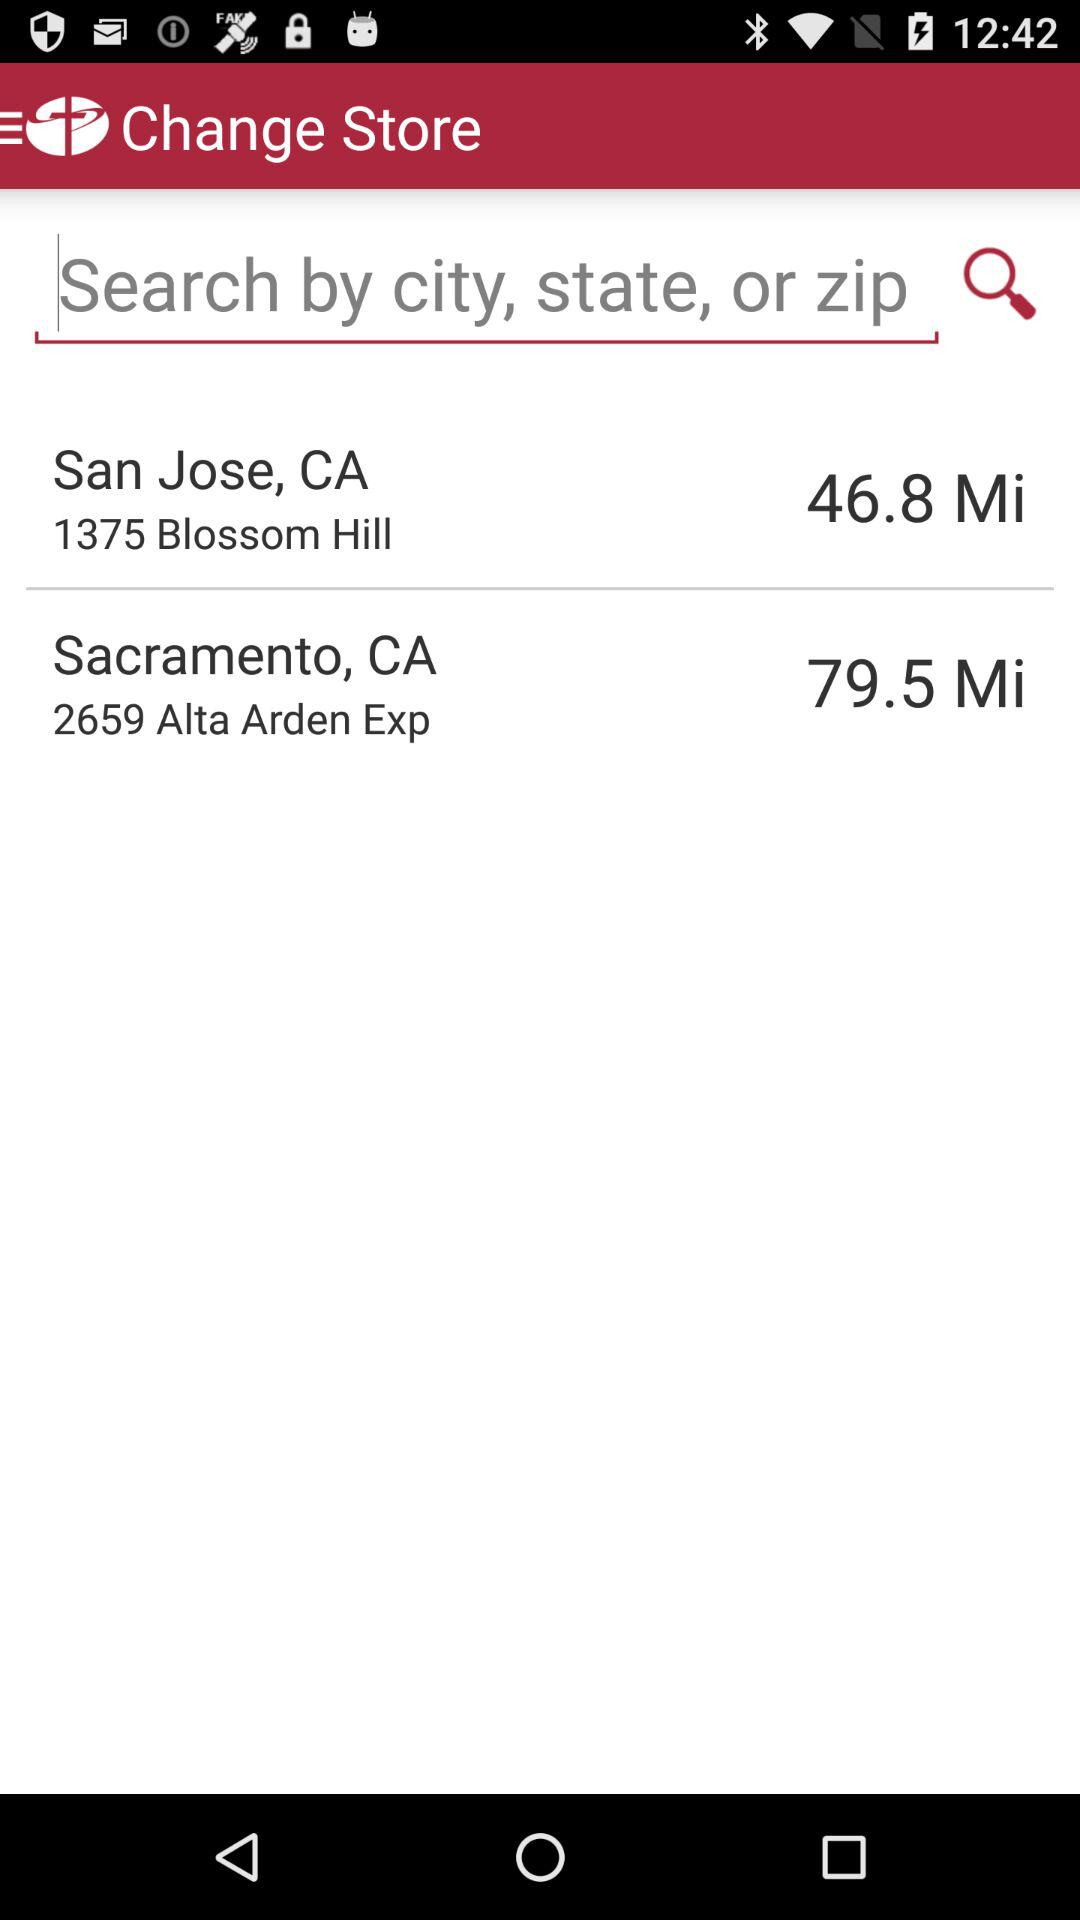What is the distance between San Jose, CA, and my location? The distance between San Jose, CA, and my location is 46.8 miles. 